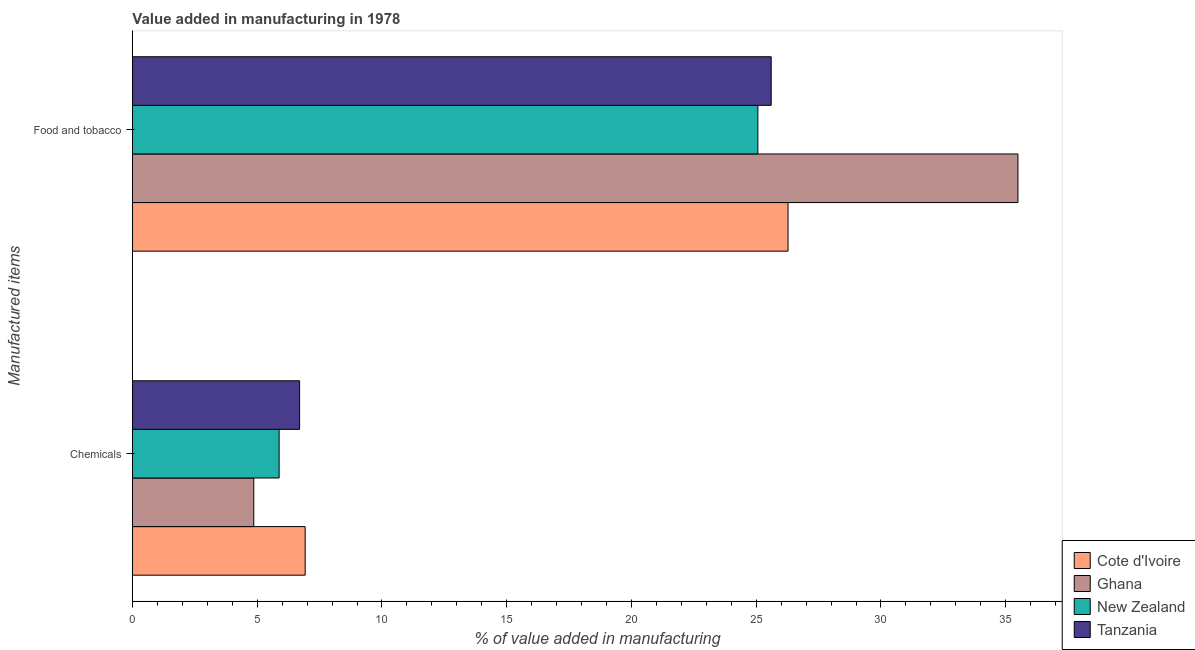How many different coloured bars are there?
Keep it short and to the point. 4. Are the number of bars per tick equal to the number of legend labels?
Your answer should be compact. Yes. How many bars are there on the 2nd tick from the top?
Provide a short and direct response. 4. What is the label of the 2nd group of bars from the top?
Offer a terse response. Chemicals. What is the value added by  manufacturing chemicals in New Zealand?
Provide a succinct answer. 5.88. Across all countries, what is the maximum value added by manufacturing food and tobacco?
Your answer should be compact. 35.49. Across all countries, what is the minimum value added by manufacturing food and tobacco?
Make the answer very short. 25.07. In which country was the value added by  manufacturing chemicals maximum?
Provide a short and direct response. Cote d'Ivoire. In which country was the value added by manufacturing food and tobacco minimum?
Your answer should be very brief. New Zealand. What is the total value added by  manufacturing chemicals in the graph?
Give a very brief answer. 24.36. What is the difference between the value added by manufacturing food and tobacco in Ghana and that in New Zealand?
Your answer should be very brief. 10.42. What is the difference between the value added by  manufacturing chemicals in Cote d'Ivoire and the value added by manufacturing food and tobacco in Tanzania?
Give a very brief answer. -18.68. What is the average value added by manufacturing food and tobacco per country?
Your response must be concise. 28.11. What is the difference between the value added by manufacturing food and tobacco and value added by  manufacturing chemicals in Cote d'Ivoire?
Your answer should be compact. 19.35. What is the ratio of the value added by  manufacturing chemicals in Cote d'Ivoire to that in New Zealand?
Offer a terse response. 1.18. Is the value added by manufacturing food and tobacco in New Zealand less than that in Ghana?
Provide a succinct answer. Yes. In how many countries, is the value added by manufacturing food and tobacco greater than the average value added by manufacturing food and tobacco taken over all countries?
Keep it short and to the point. 1. What does the 3rd bar from the bottom in Chemicals represents?
Your response must be concise. New Zealand. How many bars are there?
Provide a succinct answer. 8. Are all the bars in the graph horizontal?
Offer a terse response. Yes. Does the graph contain any zero values?
Give a very brief answer. No. How many legend labels are there?
Provide a short and direct response. 4. How are the legend labels stacked?
Keep it short and to the point. Vertical. What is the title of the graph?
Make the answer very short. Value added in manufacturing in 1978. What is the label or title of the X-axis?
Your response must be concise. % of value added in manufacturing. What is the label or title of the Y-axis?
Provide a succinct answer. Manufactured items. What is the % of value added in manufacturing in Cote d'Ivoire in Chemicals?
Your answer should be compact. 6.92. What is the % of value added in manufacturing of Ghana in Chemicals?
Your response must be concise. 4.86. What is the % of value added in manufacturing in New Zealand in Chemicals?
Your answer should be compact. 5.88. What is the % of value added in manufacturing in Tanzania in Chemicals?
Your response must be concise. 6.7. What is the % of value added in manufacturing of Cote d'Ivoire in Food and tobacco?
Ensure brevity in your answer.  26.27. What is the % of value added in manufacturing in Ghana in Food and tobacco?
Give a very brief answer. 35.49. What is the % of value added in manufacturing in New Zealand in Food and tobacco?
Provide a succinct answer. 25.07. What is the % of value added in manufacturing of Tanzania in Food and tobacco?
Offer a terse response. 25.6. Across all Manufactured items, what is the maximum % of value added in manufacturing of Cote d'Ivoire?
Ensure brevity in your answer.  26.27. Across all Manufactured items, what is the maximum % of value added in manufacturing of Ghana?
Give a very brief answer. 35.49. Across all Manufactured items, what is the maximum % of value added in manufacturing of New Zealand?
Your response must be concise. 25.07. Across all Manufactured items, what is the maximum % of value added in manufacturing in Tanzania?
Make the answer very short. 25.6. Across all Manufactured items, what is the minimum % of value added in manufacturing of Cote d'Ivoire?
Your response must be concise. 6.92. Across all Manufactured items, what is the minimum % of value added in manufacturing of Ghana?
Make the answer very short. 4.86. Across all Manufactured items, what is the minimum % of value added in manufacturing in New Zealand?
Keep it short and to the point. 5.88. Across all Manufactured items, what is the minimum % of value added in manufacturing of Tanzania?
Provide a short and direct response. 6.7. What is the total % of value added in manufacturing in Cote d'Ivoire in the graph?
Your answer should be compact. 33.2. What is the total % of value added in manufacturing in Ghana in the graph?
Offer a terse response. 40.35. What is the total % of value added in manufacturing in New Zealand in the graph?
Keep it short and to the point. 30.94. What is the total % of value added in manufacturing of Tanzania in the graph?
Your response must be concise. 32.3. What is the difference between the % of value added in manufacturing in Cote d'Ivoire in Chemicals and that in Food and tobacco?
Keep it short and to the point. -19.35. What is the difference between the % of value added in manufacturing in Ghana in Chemicals and that in Food and tobacco?
Your response must be concise. -30.63. What is the difference between the % of value added in manufacturing in New Zealand in Chemicals and that in Food and tobacco?
Provide a succinct answer. -19.19. What is the difference between the % of value added in manufacturing of Tanzania in Chemicals and that in Food and tobacco?
Offer a very short reply. -18.9. What is the difference between the % of value added in manufacturing in Cote d'Ivoire in Chemicals and the % of value added in manufacturing in Ghana in Food and tobacco?
Offer a very short reply. -28.57. What is the difference between the % of value added in manufacturing of Cote d'Ivoire in Chemicals and the % of value added in manufacturing of New Zealand in Food and tobacco?
Offer a terse response. -18.14. What is the difference between the % of value added in manufacturing in Cote d'Ivoire in Chemicals and the % of value added in manufacturing in Tanzania in Food and tobacco?
Ensure brevity in your answer.  -18.68. What is the difference between the % of value added in manufacturing of Ghana in Chemicals and the % of value added in manufacturing of New Zealand in Food and tobacco?
Offer a terse response. -20.2. What is the difference between the % of value added in manufacturing of Ghana in Chemicals and the % of value added in manufacturing of Tanzania in Food and tobacco?
Your response must be concise. -20.74. What is the difference between the % of value added in manufacturing in New Zealand in Chemicals and the % of value added in manufacturing in Tanzania in Food and tobacco?
Ensure brevity in your answer.  -19.72. What is the average % of value added in manufacturing of Cote d'Ivoire per Manufactured items?
Offer a very short reply. 16.6. What is the average % of value added in manufacturing of Ghana per Manufactured items?
Offer a very short reply. 20.18. What is the average % of value added in manufacturing of New Zealand per Manufactured items?
Give a very brief answer. 15.47. What is the average % of value added in manufacturing in Tanzania per Manufactured items?
Your answer should be very brief. 16.15. What is the difference between the % of value added in manufacturing of Cote d'Ivoire and % of value added in manufacturing of Ghana in Chemicals?
Your response must be concise. 2.06. What is the difference between the % of value added in manufacturing in Cote d'Ivoire and % of value added in manufacturing in New Zealand in Chemicals?
Your answer should be compact. 1.04. What is the difference between the % of value added in manufacturing of Cote d'Ivoire and % of value added in manufacturing of Tanzania in Chemicals?
Your answer should be compact. 0.22. What is the difference between the % of value added in manufacturing in Ghana and % of value added in manufacturing in New Zealand in Chemicals?
Ensure brevity in your answer.  -1.02. What is the difference between the % of value added in manufacturing of Ghana and % of value added in manufacturing of Tanzania in Chemicals?
Your answer should be compact. -1.84. What is the difference between the % of value added in manufacturing in New Zealand and % of value added in manufacturing in Tanzania in Chemicals?
Ensure brevity in your answer.  -0.82. What is the difference between the % of value added in manufacturing of Cote d'Ivoire and % of value added in manufacturing of Ghana in Food and tobacco?
Offer a terse response. -9.21. What is the difference between the % of value added in manufacturing in Cote d'Ivoire and % of value added in manufacturing in New Zealand in Food and tobacco?
Your response must be concise. 1.21. What is the difference between the % of value added in manufacturing in Cote d'Ivoire and % of value added in manufacturing in Tanzania in Food and tobacco?
Your answer should be compact. 0.67. What is the difference between the % of value added in manufacturing in Ghana and % of value added in manufacturing in New Zealand in Food and tobacco?
Offer a very short reply. 10.42. What is the difference between the % of value added in manufacturing in Ghana and % of value added in manufacturing in Tanzania in Food and tobacco?
Your answer should be compact. 9.89. What is the difference between the % of value added in manufacturing in New Zealand and % of value added in manufacturing in Tanzania in Food and tobacco?
Keep it short and to the point. -0.53. What is the ratio of the % of value added in manufacturing in Cote d'Ivoire in Chemicals to that in Food and tobacco?
Your answer should be very brief. 0.26. What is the ratio of the % of value added in manufacturing in Ghana in Chemicals to that in Food and tobacco?
Provide a succinct answer. 0.14. What is the ratio of the % of value added in manufacturing of New Zealand in Chemicals to that in Food and tobacco?
Give a very brief answer. 0.23. What is the ratio of the % of value added in manufacturing in Tanzania in Chemicals to that in Food and tobacco?
Offer a very short reply. 0.26. What is the difference between the highest and the second highest % of value added in manufacturing in Cote d'Ivoire?
Your answer should be very brief. 19.35. What is the difference between the highest and the second highest % of value added in manufacturing of Ghana?
Provide a short and direct response. 30.63. What is the difference between the highest and the second highest % of value added in manufacturing of New Zealand?
Your answer should be very brief. 19.19. What is the difference between the highest and the lowest % of value added in manufacturing in Cote d'Ivoire?
Provide a succinct answer. 19.35. What is the difference between the highest and the lowest % of value added in manufacturing of Ghana?
Your response must be concise. 30.63. What is the difference between the highest and the lowest % of value added in manufacturing in New Zealand?
Provide a succinct answer. 19.19. What is the difference between the highest and the lowest % of value added in manufacturing of Tanzania?
Give a very brief answer. 18.9. 